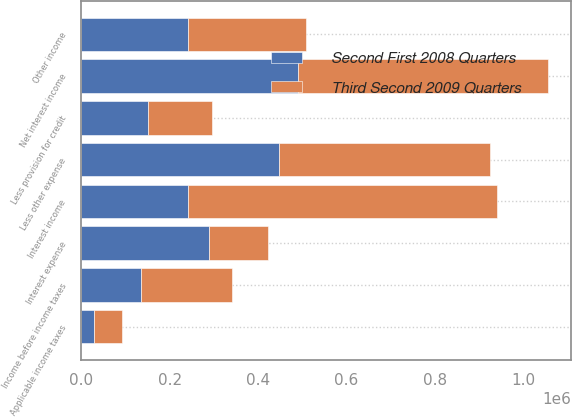Convert chart to OTSL. <chart><loc_0><loc_0><loc_500><loc_500><stacked_bar_chart><ecel><fcel>Interest income<fcel>Interest expense<fcel>Net interest income<fcel>Less provision for credit<fcel>Other income<fcel>Less other expense<fcel>Income before income taxes<fcel>Applicable income taxes<nl><fcel>Third Second 2009 Quarters<fcel>698556<fcel>133950<fcel>564606<fcel>145000<fcel>265890<fcel>478451<fcel>207045<fcel>64340<nl><fcel>Second First 2008 Quarters<fcel>241417<fcel>288426<fcel>491042<fcel>151000<fcel>241417<fcel>446819<fcel>134640<fcel>27432<nl></chart> 